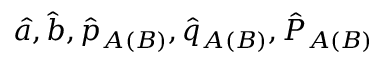<formula> <loc_0><loc_0><loc_500><loc_500>\hat { a } , \hat { b } , \hat { p } _ { A ( B ) } , \hat { q } _ { A ( B ) } , \hat { P } _ { A ( B ) }</formula> 